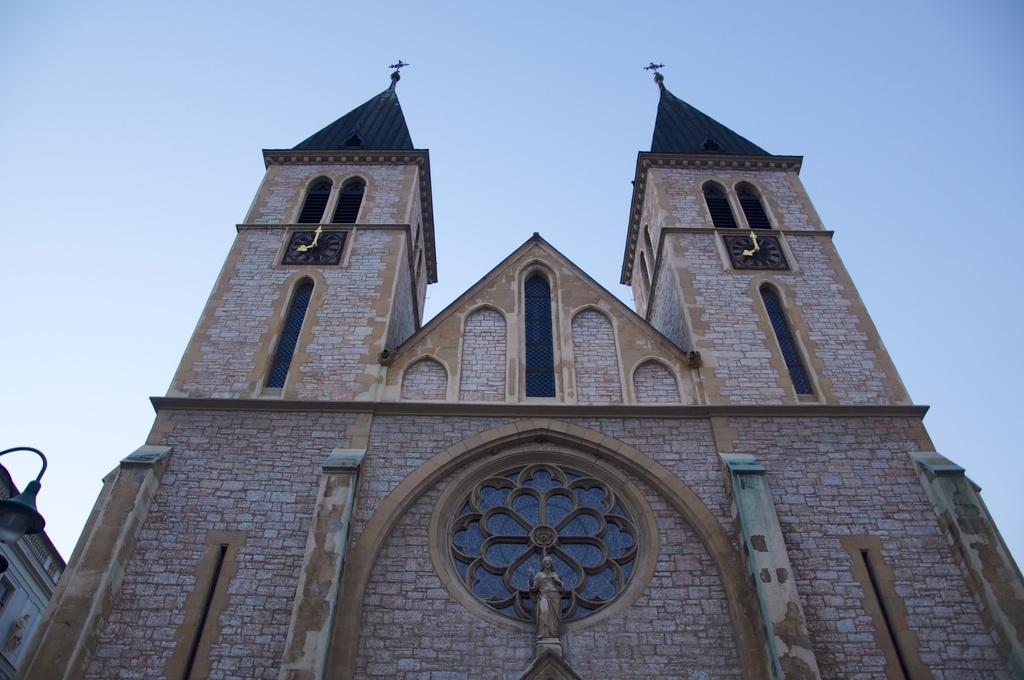Please provide a concise description of this image. In this image there is a church, in the background there is the sky. 